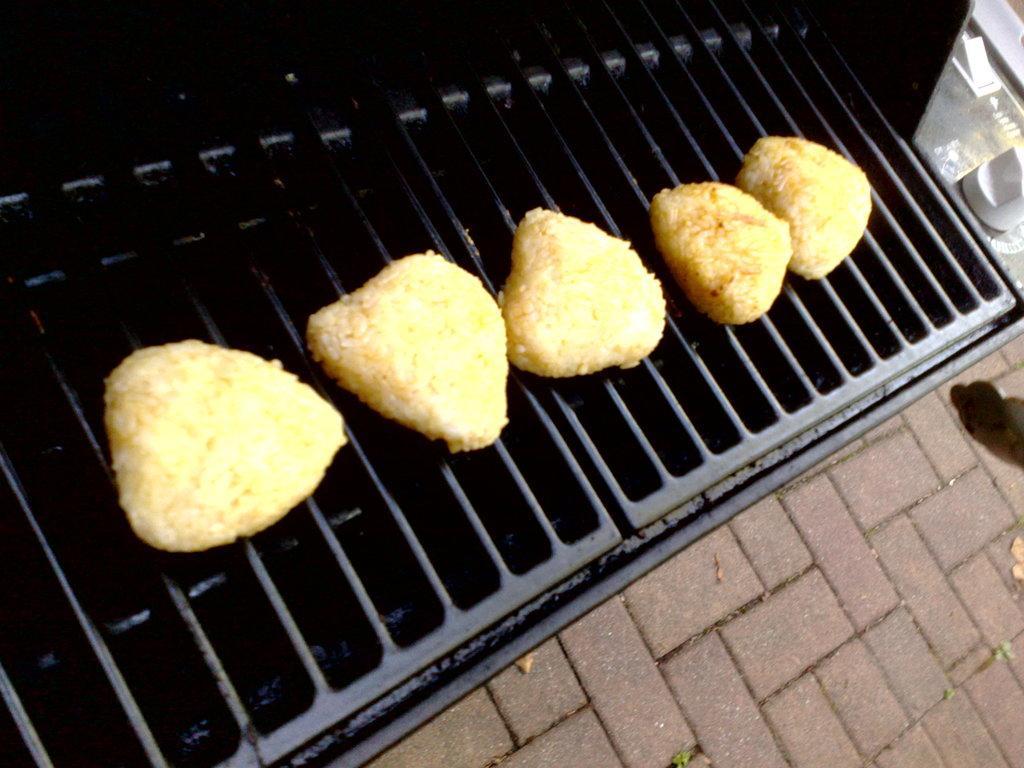Could you give a brief overview of what you see in this image? In this image we can see food item on grills. In the bottom right we can see a surface. In the top right, we can see a white object. 